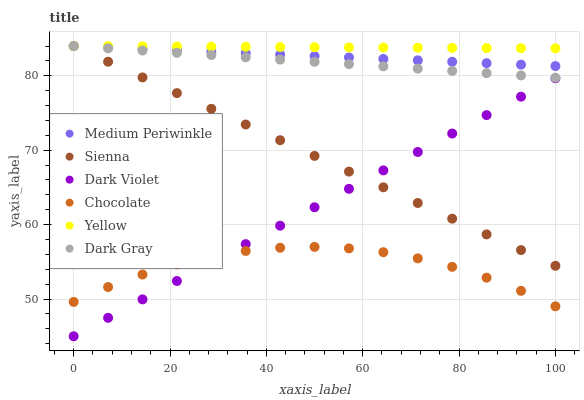Does Chocolate have the minimum area under the curve?
Answer yes or no. Yes. Does Yellow have the maximum area under the curve?
Answer yes or no. Yes. Does Medium Periwinkle have the minimum area under the curve?
Answer yes or no. No. Does Medium Periwinkle have the maximum area under the curve?
Answer yes or no. No. Is Sienna the smoothest?
Answer yes or no. Yes. Is Chocolate the roughest?
Answer yes or no. Yes. Is Medium Periwinkle the smoothest?
Answer yes or no. No. Is Medium Periwinkle the roughest?
Answer yes or no. No. Does Dark Violet have the lowest value?
Answer yes or no. Yes. Does Medium Periwinkle have the lowest value?
Answer yes or no. No. Does Sienna have the highest value?
Answer yes or no. Yes. Does Chocolate have the highest value?
Answer yes or no. No. Is Dark Violet less than Medium Periwinkle?
Answer yes or no. Yes. Is Yellow greater than Chocolate?
Answer yes or no. Yes. Does Dark Gray intersect Sienna?
Answer yes or no. Yes. Is Dark Gray less than Sienna?
Answer yes or no. No. Is Dark Gray greater than Sienna?
Answer yes or no. No. Does Dark Violet intersect Medium Periwinkle?
Answer yes or no. No. 